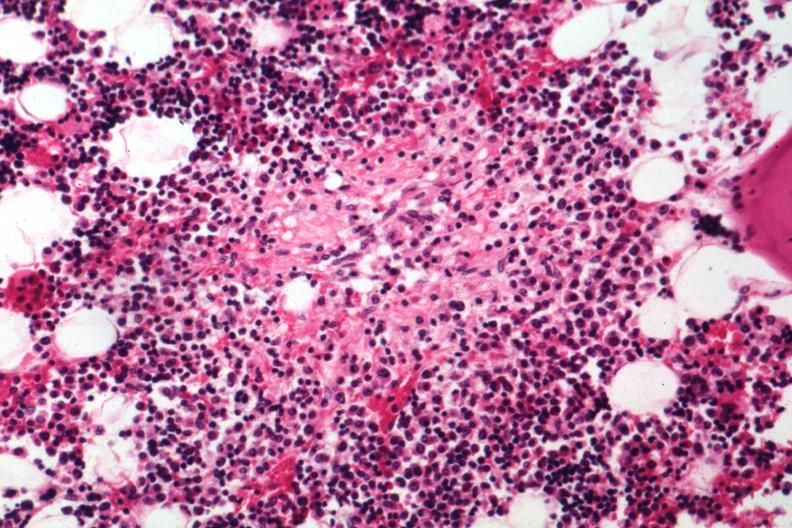s tuberculosis present?
Answer the question using a single word or phrase. Yes 